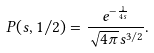Convert formula to latex. <formula><loc_0><loc_0><loc_500><loc_500>P ( s , 1 / 2 ) = \frac { e ^ { - \frac { 1 } { 4 s } } } { \sqrt { 4 \pi } s ^ { 3 / 2 } } .</formula> 